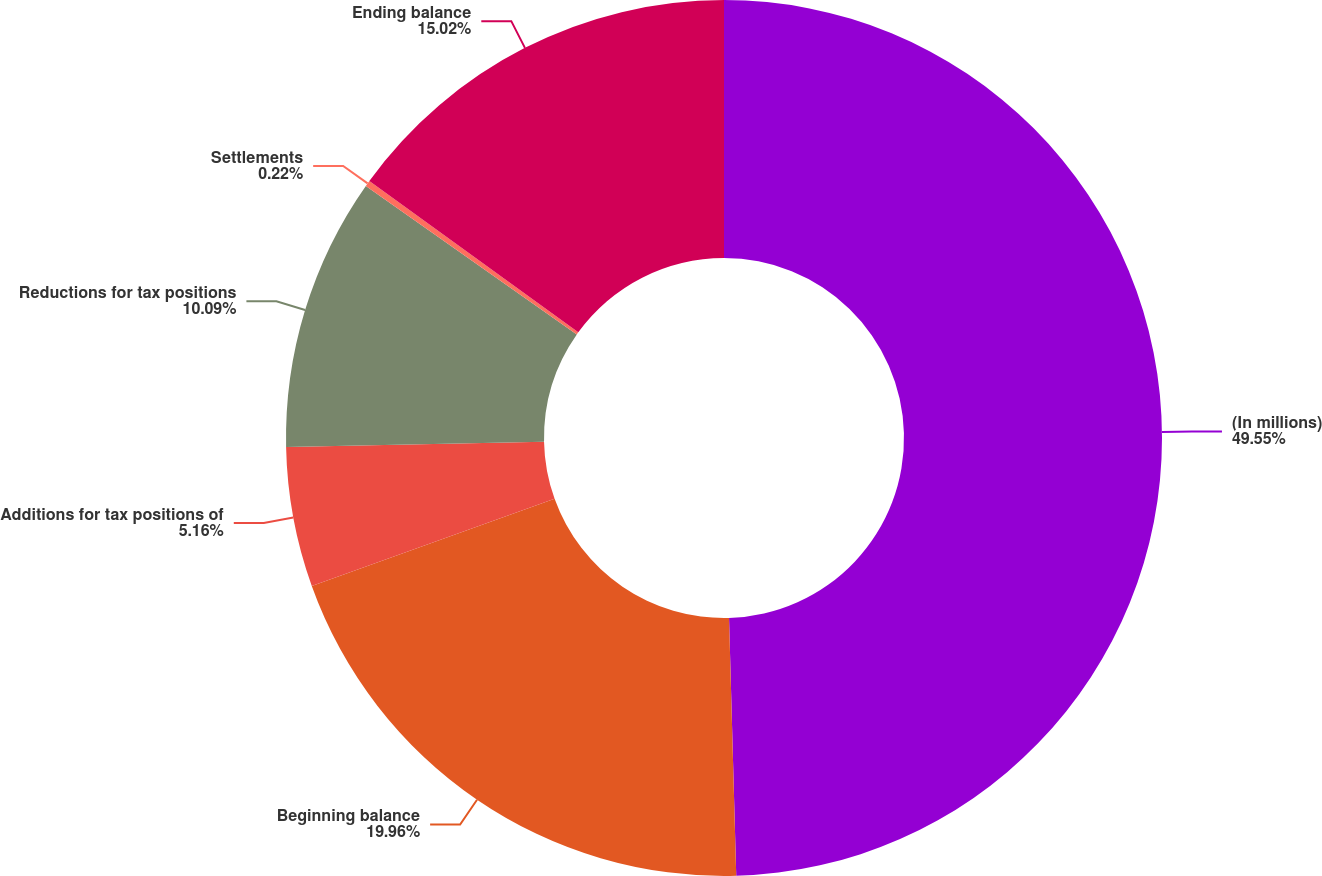Convert chart. <chart><loc_0><loc_0><loc_500><loc_500><pie_chart><fcel>(In millions)<fcel>Beginning balance<fcel>Additions for tax positions of<fcel>Reductions for tax positions<fcel>Settlements<fcel>Ending balance<nl><fcel>49.56%<fcel>19.96%<fcel>5.16%<fcel>10.09%<fcel>0.22%<fcel>15.02%<nl></chart> 